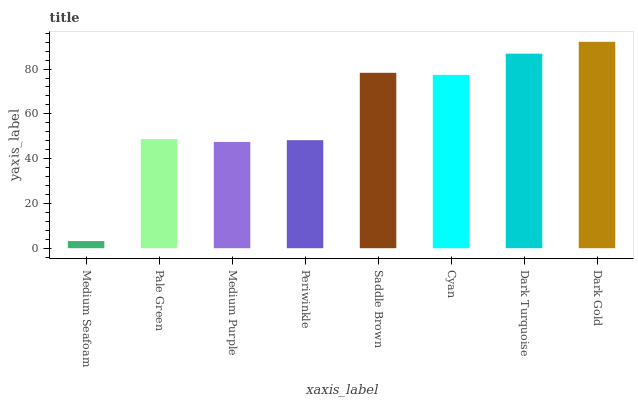Is Medium Seafoam the minimum?
Answer yes or no. Yes. Is Dark Gold the maximum?
Answer yes or no. Yes. Is Pale Green the minimum?
Answer yes or no. No. Is Pale Green the maximum?
Answer yes or no. No. Is Pale Green greater than Medium Seafoam?
Answer yes or no. Yes. Is Medium Seafoam less than Pale Green?
Answer yes or no. Yes. Is Medium Seafoam greater than Pale Green?
Answer yes or no. No. Is Pale Green less than Medium Seafoam?
Answer yes or no. No. Is Cyan the high median?
Answer yes or no. Yes. Is Pale Green the low median?
Answer yes or no. Yes. Is Medium Seafoam the high median?
Answer yes or no. No. Is Periwinkle the low median?
Answer yes or no. No. 